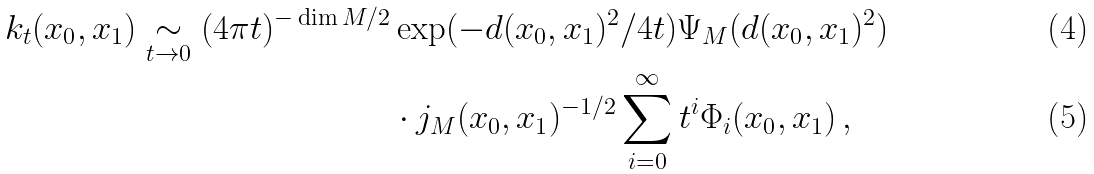<formula> <loc_0><loc_0><loc_500><loc_500>k _ { t } ( x _ { 0 } , x _ { 1 } ) \underset { t \rightarrow 0 } { \sim } ( 4 \pi t ) ^ { - \dim M / 2 } & \exp ( - d ( x _ { 0 } , x _ { 1 } ) ^ { 2 } / 4 t ) \Psi _ { M } ( d ( x _ { 0 } , x _ { 1 } ) ^ { 2 } ) \\ & \cdot j _ { M } ( x _ { 0 } , x _ { 1 } ) ^ { - 1 / 2 } \sum _ { i = 0 } ^ { \infty } t ^ { i } \Phi _ { i } ( x _ { 0 } , x _ { 1 } ) \, ,</formula> 